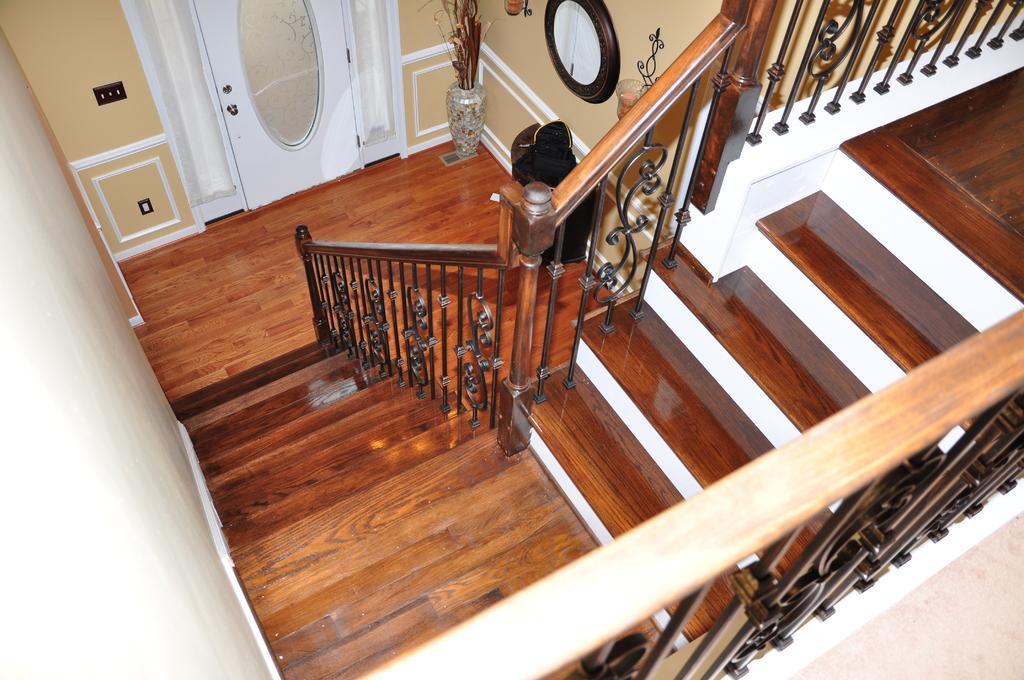In one or two sentences, can you explain what this image depicts? In this picture we can see steps, fence, door, floor, flower pot, lamps and in the background we can see the wall. 